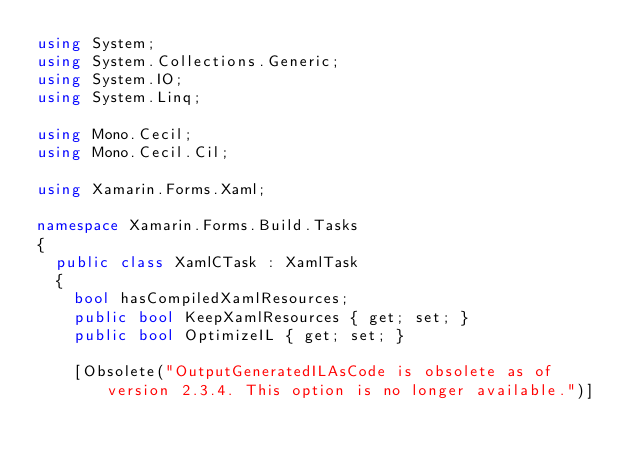Convert code to text. <code><loc_0><loc_0><loc_500><loc_500><_C#_>using System;
using System.Collections.Generic;
using System.IO;
using System.Linq;

using Mono.Cecil;
using Mono.Cecil.Cil;

using Xamarin.Forms.Xaml;

namespace Xamarin.Forms.Build.Tasks
{
	public class XamlCTask : XamlTask
	{
		bool hasCompiledXamlResources;
		public bool KeepXamlResources { get; set; }
		public bool OptimizeIL { get; set; }

		[Obsolete("OutputGeneratedILAsCode is obsolete as of version 2.3.4. This option is no longer available.")]</code> 